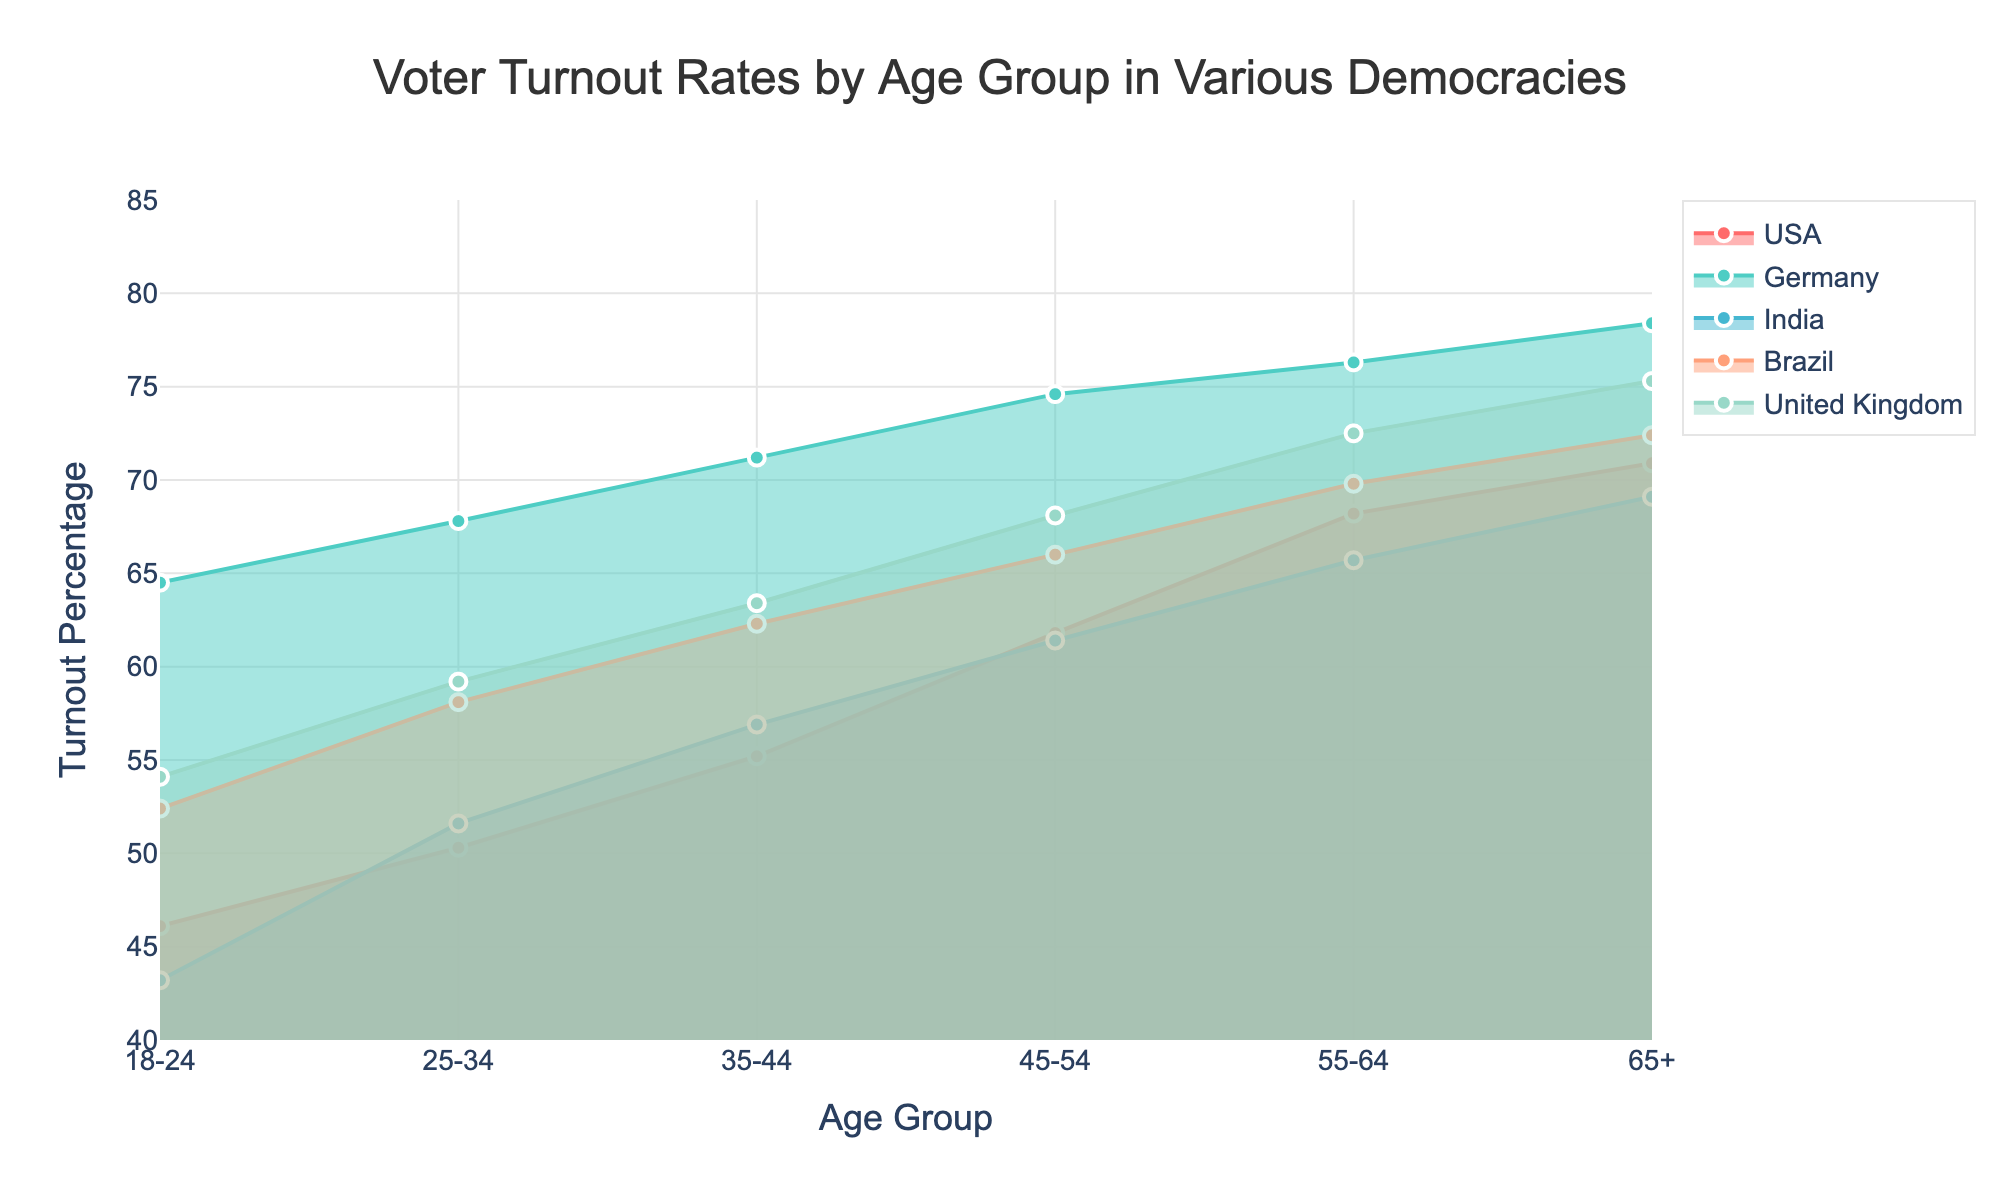What is the title of the chart? The title can be found at the top-center of the chart.
Answer: Voter Turnout Rates by Age Group in Various Democracies How many age groups are represented in the chart? Count the distinct age groups along the x-axis.
Answer: 6 Which country has the highest voter turnout rate among the 18-24 age group? Look at the data line or marker of each country for the 18-24 age group and compare the values.
Answer: Germany What is the voter turnout rate for the 65+ age group in the United Kingdom? Locate the data line for the United Kingdom and find the value at the 65+ age group on the x-axis.
Answer: 75.3% Is the voter turnout rate for the 45-54 age group in Brazil higher or lower than in India? Compare the turnout percentage for the 45-54 age group between Brazil and India.
Answer: Higher What is the overall trend in voter turnout rates as age increases across all countries? Observe the general direction of the data lines with increasing age groups on the x-axis.
Answer: Increasing trend Which age group sees the largest increase in voter turnout rates between the USA and Germany? Calculate the difference in voter turnout rates for each age group between the USA and Germany, then find the largest difference.
Answer: 18-24 On average, which country has the highest voter turnout rate across all age groups? Calculate the mean voter turnout rate for each country across all age groups and compare the averages.
Answer: Germany What is the difference in voter turnout rate for the 55-64 age group between the USA and Brazil? Subtract the voter turnout rate of the 55-64 age group in the USA from that of Brazil.
Answer: 1.6% How does the voter turnout rate of the 25-34 age group in India compare to that in the USA? Compare the turnout percentage for the 25-34 age group between India and the USA.
Answer: Lower 